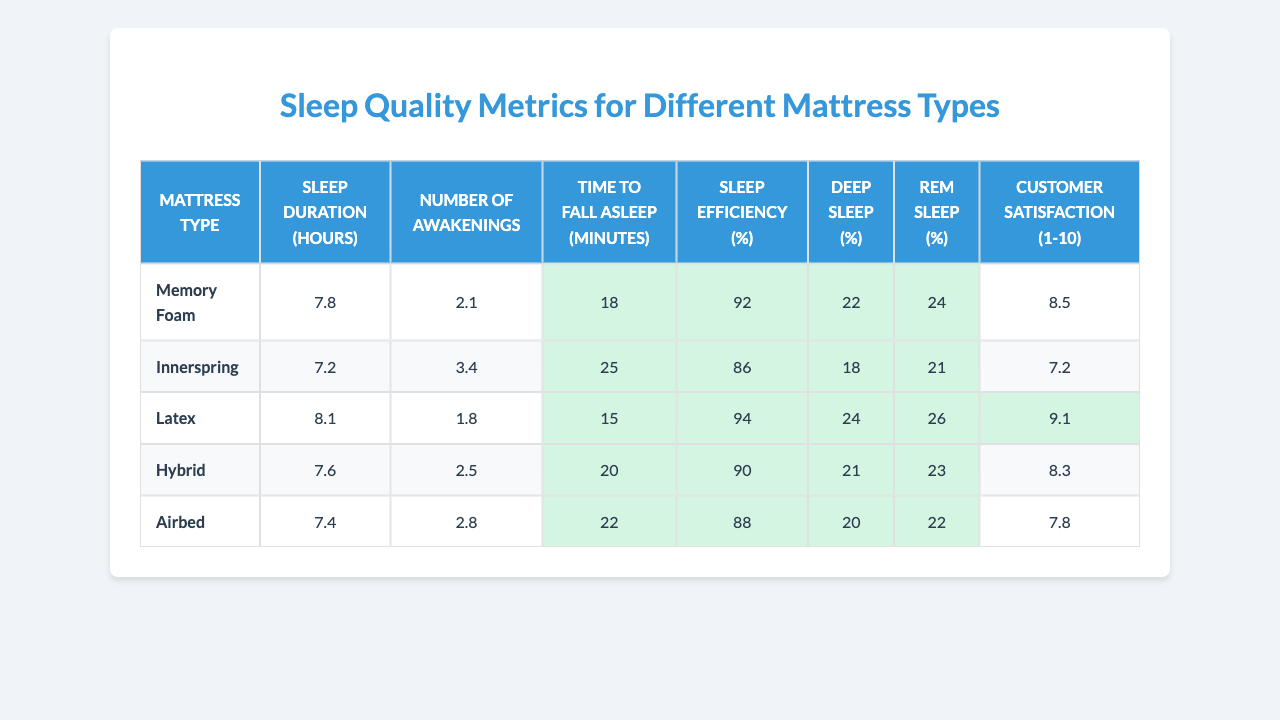What is the mattress type with the highest customer satisfaction? From the table, I can see the customer satisfaction ratings for each mattress type. Memory Foam has a rating of 8.5, Innerspring has 7.2, Latex has 9.1, Hybrid has 8.3, and Airbed has 7.8. The highest rating is 9.1, which belongs to the Latex mattress.
Answer: Latex How many hours of sleep do people generally get on a Memory Foam mattress? Referring to the table, the Sleep Duration for the Memory Foam mattress type is specified, which is 7.8 hours.
Answer: 7.8 hours What is the average number of awakenings across all mattress types? To find the average number of awakenings, I sum the number of awakenings for each type: (2.1 + 3.4 + 1.8 + 2.5 + 2.8) = 12.6. Then, I divide this sum by the number of mattress types, which is 5: 12.6 / 5 = 2.52.
Answer: 2.52 Is the Deep Sleep percentage higher for Hybrid mattresses compared to Innerspring mattresses? Looking at the data, the Deep Sleep percentage for Hybrid is 21%, while for Innerspring it is 18%. Since 21% is greater than 18%, this statement is true.
Answer: Yes What is the difference in Sleep Efficiency between Latex and Airbed mattresses? The Sleep Efficiency for Latex is 94% and for Airbed is 88%. To find the difference, I subtract the Airbed value from the Latex value: 94 - 88 = 6. Therefore, the difference in Sleep Efficiency is 6%.
Answer: 6% Which mattress type takes the least time to fall asleep? Reviewing the Time to Fall Asleep data, Memory Foam takes 18 minutes, Innerspring takes 25 minutes, Latex takes 15 minutes, Hybrid takes 20 minutes, and Airbed takes 22 minutes. Since 15 minutes is the shortest time, the Latex mattress type takes the least time to fall asleep.
Answer: Latex Is it true that Innerspring mattresses have a Sleep Duration of less than 7.5 hours? Checking the Sleep Duration for Innerspring, it is 7.2 hours, which is indeed less than 7.5 hours. Therefore, this statement is true.
Answer: Yes What is the total percentage of Deep Sleep for all mattress types combined? To find the total percentage of Deep Sleep, I add the Deep Sleep percentages for each mattress type: (22 + 18 + 24 + 21 + 20) = 105%.
Answer: 105% How does the Time to Fall Asleep for Memory Foam compare to that of Latex? The Time to Fall Asleep for Memory Foam is 18 minutes, while for Latex it is 15 minutes. Since 18 minutes is greater than 15 minutes, Memory Foam takes longer to fall asleep than Latex.
Answer: Longer What is the average REM Sleep percentage for the mattress types listed? To calculate the average REM Sleep percentage, I first sum the REM Sleep percentages: (24 + 21 + 26 + 23 + 22) = 116. Next, I divide this by the number of mattress types, which is 5: 116 / 5 = 23.2%.
Answer: 23.2% 